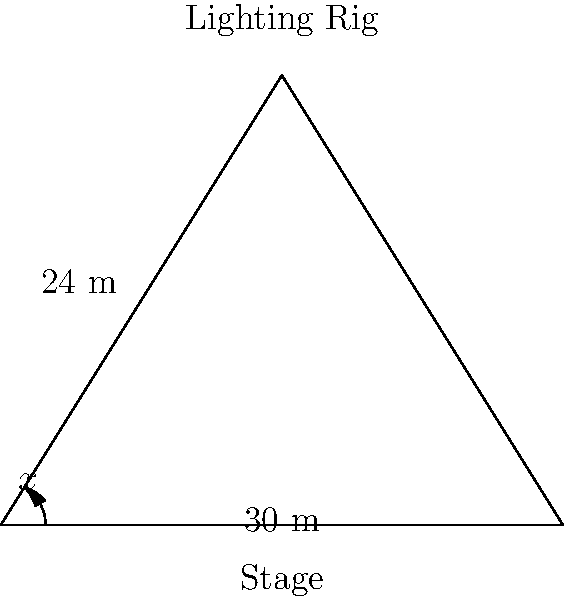In a beauty pageant venue, a lighting technician needs to determine the optimal angle for the stage lights. The lighting rig is positioned 24 meters above the center of a 30-meter wide stage. What angle $x$ (in degrees) should the lights be tilted down from the horizontal to illuminate the edge of the stage for the best effect? Let's approach this step-by-step:

1) We can treat this as a right-angled triangle problem. The stage forms the base of the triangle, and the lighting rig forms the height.

2) We know:
   - The width of the stage is 30 meters
   - The height of the lighting rig is 24 meters
   - We need to find the angle at the top of the rig to the edge of the stage

3) The angle we're looking for is formed between the horizontal line from the lighting rig and the line to the edge of the stage.

4) We can use the tangent function to find this angle:

   $\tan(x) = \frac{\text{opposite}}{\text{adjacent}}$

5) In our case:
   - The opposite side is the height of the rig: 24 meters
   - The adjacent side is half the width of the stage: 15 meters (since the rig is centered)

6) Plugging these into our equation:

   $\tan(x) = \frac{24}{15}$

7) To find $x$, we need to use the inverse tangent (arctan or $\tan^{-1}$):

   $x = \tan^{-1}(\frac{24}{15})$

8) Using a calculator or computer:

   $x \approx 57.99$ degrees

9) Rounding to two decimal places:

   $x \approx 58.00$ degrees

Therefore, the lights should be tilted down at an angle of approximately 58.00 degrees from the horizontal.
Answer: $58.00°$ 